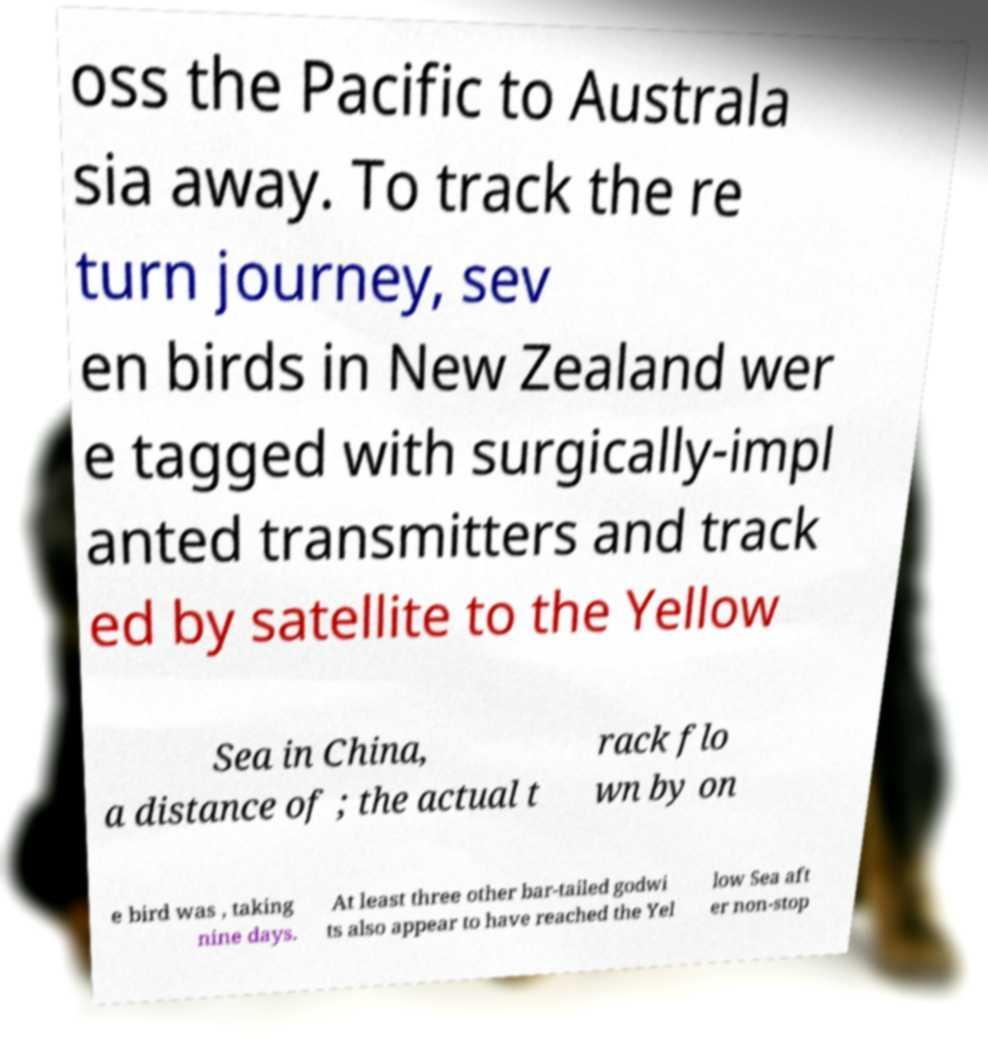Please read and relay the text visible in this image. What does it say? oss the Pacific to Australa sia away. To track the re turn journey, sev en birds in New Zealand wer e tagged with surgically-impl anted transmitters and track ed by satellite to the Yellow Sea in China, a distance of ; the actual t rack flo wn by on e bird was , taking nine days. At least three other bar-tailed godwi ts also appear to have reached the Yel low Sea aft er non-stop 